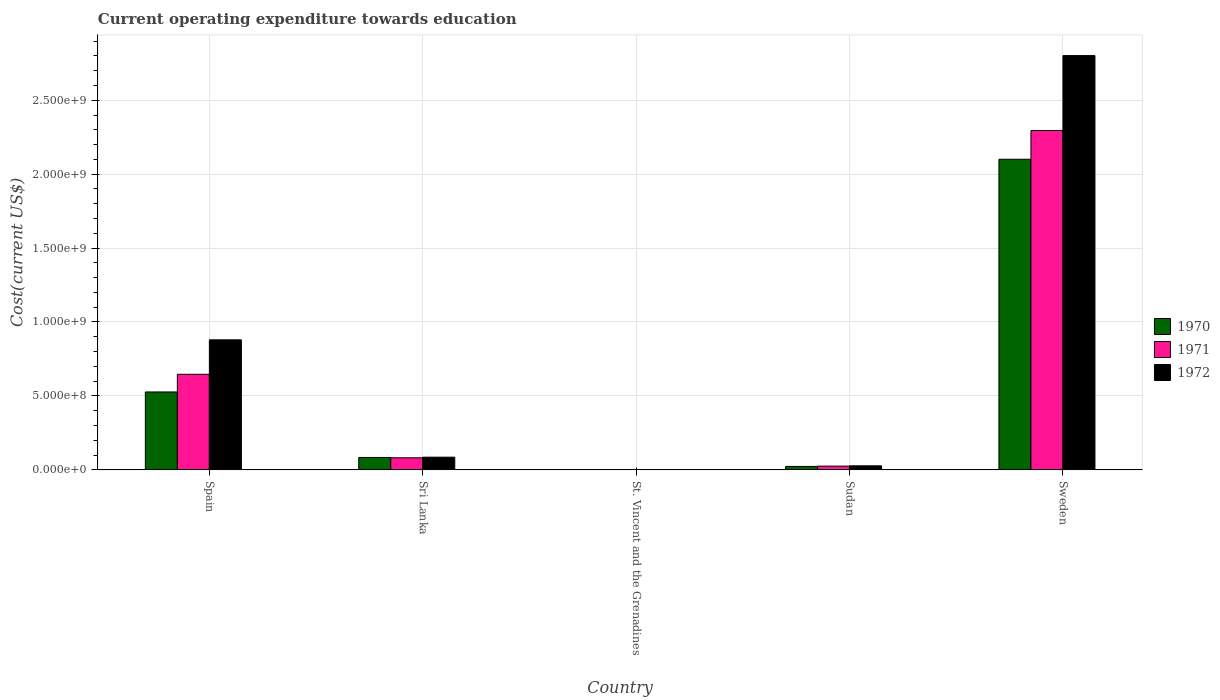How many different coloured bars are there?
Make the answer very short. 3. How many groups of bars are there?
Your response must be concise. 5. Are the number of bars per tick equal to the number of legend labels?
Provide a succinct answer. Yes. Are the number of bars on each tick of the X-axis equal?
Offer a very short reply. Yes. How many bars are there on the 5th tick from the left?
Provide a succinct answer. 3. What is the label of the 4th group of bars from the left?
Provide a succinct answer. Sudan. In how many cases, is the number of bars for a given country not equal to the number of legend labels?
Give a very brief answer. 0. What is the expenditure towards education in 1972 in Sweden?
Offer a terse response. 2.80e+09. Across all countries, what is the maximum expenditure towards education in 1971?
Offer a very short reply. 2.30e+09. Across all countries, what is the minimum expenditure towards education in 1971?
Offer a very short reply. 1.64e+06. In which country was the expenditure towards education in 1971 minimum?
Your response must be concise. St. Vincent and the Grenadines. What is the total expenditure towards education in 1971 in the graph?
Keep it short and to the point. 3.05e+09. What is the difference between the expenditure towards education in 1970 in Spain and that in Sudan?
Your response must be concise. 5.04e+08. What is the difference between the expenditure towards education in 1972 in Spain and the expenditure towards education in 1970 in Sweden?
Provide a short and direct response. -1.22e+09. What is the average expenditure towards education in 1970 per country?
Provide a succinct answer. 5.47e+08. What is the difference between the expenditure towards education of/in 1972 and expenditure towards education of/in 1970 in Sri Lanka?
Give a very brief answer. 1.91e+06. What is the ratio of the expenditure towards education in 1970 in Spain to that in Sri Lanka?
Ensure brevity in your answer.  6.3. Is the difference between the expenditure towards education in 1972 in Spain and St. Vincent and the Grenadines greater than the difference between the expenditure towards education in 1970 in Spain and St. Vincent and the Grenadines?
Ensure brevity in your answer.  Yes. What is the difference between the highest and the second highest expenditure towards education in 1972?
Keep it short and to the point. 1.92e+09. What is the difference between the highest and the lowest expenditure towards education in 1972?
Provide a short and direct response. 2.80e+09. In how many countries, is the expenditure towards education in 1971 greater than the average expenditure towards education in 1971 taken over all countries?
Your response must be concise. 2. Is the sum of the expenditure towards education in 1972 in Sudan and Sweden greater than the maximum expenditure towards education in 1971 across all countries?
Ensure brevity in your answer.  Yes. What does the 3rd bar from the left in Sudan represents?
Ensure brevity in your answer.  1972. What does the 3rd bar from the right in Sudan represents?
Your response must be concise. 1970. Is it the case that in every country, the sum of the expenditure towards education in 1971 and expenditure towards education in 1972 is greater than the expenditure towards education in 1970?
Your answer should be very brief. Yes. How many countries are there in the graph?
Your response must be concise. 5. Are the values on the major ticks of Y-axis written in scientific E-notation?
Give a very brief answer. Yes. Where does the legend appear in the graph?
Give a very brief answer. Center right. How many legend labels are there?
Make the answer very short. 3. What is the title of the graph?
Provide a succinct answer. Current operating expenditure towards education. What is the label or title of the X-axis?
Offer a very short reply. Country. What is the label or title of the Y-axis?
Give a very brief answer. Cost(current US$). What is the Cost(current US$) in 1970 in Spain?
Offer a terse response. 5.27e+08. What is the Cost(current US$) in 1971 in Spain?
Make the answer very short. 6.46e+08. What is the Cost(current US$) of 1972 in Spain?
Offer a terse response. 8.79e+08. What is the Cost(current US$) in 1970 in Sri Lanka?
Your answer should be very brief. 8.35e+07. What is the Cost(current US$) of 1971 in Sri Lanka?
Give a very brief answer. 8.13e+07. What is the Cost(current US$) of 1972 in Sri Lanka?
Make the answer very short. 8.55e+07. What is the Cost(current US$) in 1970 in St. Vincent and the Grenadines?
Your answer should be compact. 8.86e+05. What is the Cost(current US$) of 1971 in St. Vincent and the Grenadines?
Provide a succinct answer. 1.64e+06. What is the Cost(current US$) in 1972 in St. Vincent and the Grenadines?
Keep it short and to the point. 1.63e+06. What is the Cost(current US$) of 1970 in Sudan?
Your response must be concise. 2.29e+07. What is the Cost(current US$) in 1971 in Sudan?
Your answer should be very brief. 2.50e+07. What is the Cost(current US$) in 1972 in Sudan?
Offer a very short reply. 2.71e+07. What is the Cost(current US$) in 1970 in Sweden?
Offer a terse response. 2.10e+09. What is the Cost(current US$) in 1971 in Sweden?
Your response must be concise. 2.30e+09. What is the Cost(current US$) of 1972 in Sweden?
Provide a succinct answer. 2.80e+09. Across all countries, what is the maximum Cost(current US$) in 1970?
Your answer should be compact. 2.10e+09. Across all countries, what is the maximum Cost(current US$) in 1971?
Offer a terse response. 2.30e+09. Across all countries, what is the maximum Cost(current US$) in 1972?
Offer a very short reply. 2.80e+09. Across all countries, what is the minimum Cost(current US$) in 1970?
Your answer should be compact. 8.86e+05. Across all countries, what is the minimum Cost(current US$) of 1971?
Provide a succinct answer. 1.64e+06. Across all countries, what is the minimum Cost(current US$) of 1972?
Offer a very short reply. 1.63e+06. What is the total Cost(current US$) of 1970 in the graph?
Offer a terse response. 2.73e+09. What is the total Cost(current US$) in 1971 in the graph?
Offer a terse response. 3.05e+09. What is the total Cost(current US$) of 1972 in the graph?
Make the answer very short. 3.80e+09. What is the difference between the Cost(current US$) of 1970 in Spain and that in Sri Lanka?
Provide a succinct answer. 4.43e+08. What is the difference between the Cost(current US$) of 1971 in Spain and that in Sri Lanka?
Offer a terse response. 5.65e+08. What is the difference between the Cost(current US$) of 1972 in Spain and that in Sri Lanka?
Your response must be concise. 7.94e+08. What is the difference between the Cost(current US$) of 1970 in Spain and that in St. Vincent and the Grenadines?
Your answer should be very brief. 5.26e+08. What is the difference between the Cost(current US$) in 1971 in Spain and that in St. Vincent and the Grenadines?
Your response must be concise. 6.44e+08. What is the difference between the Cost(current US$) in 1972 in Spain and that in St. Vincent and the Grenadines?
Keep it short and to the point. 8.78e+08. What is the difference between the Cost(current US$) of 1970 in Spain and that in Sudan?
Offer a very short reply. 5.04e+08. What is the difference between the Cost(current US$) of 1971 in Spain and that in Sudan?
Make the answer very short. 6.21e+08. What is the difference between the Cost(current US$) of 1972 in Spain and that in Sudan?
Ensure brevity in your answer.  8.52e+08. What is the difference between the Cost(current US$) in 1970 in Spain and that in Sweden?
Make the answer very short. -1.57e+09. What is the difference between the Cost(current US$) in 1971 in Spain and that in Sweden?
Keep it short and to the point. -1.65e+09. What is the difference between the Cost(current US$) of 1972 in Spain and that in Sweden?
Make the answer very short. -1.92e+09. What is the difference between the Cost(current US$) in 1970 in Sri Lanka and that in St. Vincent and the Grenadines?
Provide a succinct answer. 8.27e+07. What is the difference between the Cost(current US$) in 1971 in Sri Lanka and that in St. Vincent and the Grenadines?
Ensure brevity in your answer.  7.96e+07. What is the difference between the Cost(current US$) in 1972 in Sri Lanka and that in St. Vincent and the Grenadines?
Give a very brief answer. 8.38e+07. What is the difference between the Cost(current US$) of 1970 in Sri Lanka and that in Sudan?
Make the answer very short. 6.06e+07. What is the difference between the Cost(current US$) of 1971 in Sri Lanka and that in Sudan?
Your response must be concise. 5.63e+07. What is the difference between the Cost(current US$) of 1972 in Sri Lanka and that in Sudan?
Offer a very short reply. 5.84e+07. What is the difference between the Cost(current US$) of 1970 in Sri Lanka and that in Sweden?
Keep it short and to the point. -2.02e+09. What is the difference between the Cost(current US$) in 1971 in Sri Lanka and that in Sweden?
Provide a succinct answer. -2.21e+09. What is the difference between the Cost(current US$) in 1972 in Sri Lanka and that in Sweden?
Offer a terse response. -2.72e+09. What is the difference between the Cost(current US$) of 1970 in St. Vincent and the Grenadines and that in Sudan?
Your response must be concise. -2.21e+07. What is the difference between the Cost(current US$) in 1971 in St. Vincent and the Grenadines and that in Sudan?
Your response must be concise. -2.33e+07. What is the difference between the Cost(current US$) of 1972 in St. Vincent and the Grenadines and that in Sudan?
Your answer should be very brief. -2.54e+07. What is the difference between the Cost(current US$) of 1970 in St. Vincent and the Grenadines and that in Sweden?
Your answer should be very brief. -2.10e+09. What is the difference between the Cost(current US$) of 1971 in St. Vincent and the Grenadines and that in Sweden?
Offer a very short reply. -2.29e+09. What is the difference between the Cost(current US$) in 1972 in St. Vincent and the Grenadines and that in Sweden?
Provide a succinct answer. -2.80e+09. What is the difference between the Cost(current US$) in 1970 in Sudan and that in Sweden?
Your response must be concise. -2.08e+09. What is the difference between the Cost(current US$) of 1971 in Sudan and that in Sweden?
Make the answer very short. -2.27e+09. What is the difference between the Cost(current US$) in 1972 in Sudan and that in Sweden?
Keep it short and to the point. -2.78e+09. What is the difference between the Cost(current US$) in 1970 in Spain and the Cost(current US$) in 1971 in Sri Lanka?
Keep it short and to the point. 4.45e+08. What is the difference between the Cost(current US$) in 1970 in Spain and the Cost(current US$) in 1972 in Sri Lanka?
Give a very brief answer. 4.41e+08. What is the difference between the Cost(current US$) of 1971 in Spain and the Cost(current US$) of 1972 in Sri Lanka?
Your response must be concise. 5.61e+08. What is the difference between the Cost(current US$) of 1970 in Spain and the Cost(current US$) of 1971 in St. Vincent and the Grenadines?
Your response must be concise. 5.25e+08. What is the difference between the Cost(current US$) in 1970 in Spain and the Cost(current US$) in 1972 in St. Vincent and the Grenadines?
Give a very brief answer. 5.25e+08. What is the difference between the Cost(current US$) of 1971 in Spain and the Cost(current US$) of 1972 in St. Vincent and the Grenadines?
Your answer should be very brief. 6.45e+08. What is the difference between the Cost(current US$) of 1970 in Spain and the Cost(current US$) of 1971 in Sudan?
Ensure brevity in your answer.  5.02e+08. What is the difference between the Cost(current US$) of 1970 in Spain and the Cost(current US$) of 1972 in Sudan?
Keep it short and to the point. 5.00e+08. What is the difference between the Cost(current US$) of 1971 in Spain and the Cost(current US$) of 1972 in Sudan?
Give a very brief answer. 6.19e+08. What is the difference between the Cost(current US$) in 1970 in Spain and the Cost(current US$) in 1971 in Sweden?
Your response must be concise. -1.77e+09. What is the difference between the Cost(current US$) in 1970 in Spain and the Cost(current US$) in 1972 in Sweden?
Your answer should be very brief. -2.28e+09. What is the difference between the Cost(current US$) of 1971 in Spain and the Cost(current US$) of 1972 in Sweden?
Make the answer very short. -2.16e+09. What is the difference between the Cost(current US$) in 1970 in Sri Lanka and the Cost(current US$) in 1971 in St. Vincent and the Grenadines?
Your response must be concise. 8.19e+07. What is the difference between the Cost(current US$) of 1970 in Sri Lanka and the Cost(current US$) of 1972 in St. Vincent and the Grenadines?
Your response must be concise. 8.19e+07. What is the difference between the Cost(current US$) in 1971 in Sri Lanka and the Cost(current US$) in 1972 in St. Vincent and the Grenadines?
Ensure brevity in your answer.  7.97e+07. What is the difference between the Cost(current US$) in 1970 in Sri Lanka and the Cost(current US$) in 1971 in Sudan?
Offer a terse response. 5.86e+07. What is the difference between the Cost(current US$) of 1970 in Sri Lanka and the Cost(current US$) of 1972 in Sudan?
Offer a very short reply. 5.65e+07. What is the difference between the Cost(current US$) in 1971 in Sri Lanka and the Cost(current US$) in 1972 in Sudan?
Your answer should be compact. 5.42e+07. What is the difference between the Cost(current US$) in 1970 in Sri Lanka and the Cost(current US$) in 1971 in Sweden?
Your response must be concise. -2.21e+09. What is the difference between the Cost(current US$) of 1970 in Sri Lanka and the Cost(current US$) of 1972 in Sweden?
Your answer should be very brief. -2.72e+09. What is the difference between the Cost(current US$) in 1971 in Sri Lanka and the Cost(current US$) in 1972 in Sweden?
Provide a succinct answer. -2.72e+09. What is the difference between the Cost(current US$) in 1970 in St. Vincent and the Grenadines and the Cost(current US$) in 1971 in Sudan?
Offer a terse response. -2.41e+07. What is the difference between the Cost(current US$) of 1970 in St. Vincent and the Grenadines and the Cost(current US$) of 1972 in Sudan?
Keep it short and to the point. -2.62e+07. What is the difference between the Cost(current US$) in 1971 in St. Vincent and the Grenadines and the Cost(current US$) in 1972 in Sudan?
Your response must be concise. -2.54e+07. What is the difference between the Cost(current US$) in 1970 in St. Vincent and the Grenadines and the Cost(current US$) in 1971 in Sweden?
Provide a succinct answer. -2.29e+09. What is the difference between the Cost(current US$) of 1970 in St. Vincent and the Grenadines and the Cost(current US$) of 1972 in Sweden?
Your response must be concise. -2.80e+09. What is the difference between the Cost(current US$) of 1971 in St. Vincent and the Grenadines and the Cost(current US$) of 1972 in Sweden?
Your response must be concise. -2.80e+09. What is the difference between the Cost(current US$) in 1970 in Sudan and the Cost(current US$) in 1971 in Sweden?
Your response must be concise. -2.27e+09. What is the difference between the Cost(current US$) in 1970 in Sudan and the Cost(current US$) in 1972 in Sweden?
Ensure brevity in your answer.  -2.78e+09. What is the difference between the Cost(current US$) of 1971 in Sudan and the Cost(current US$) of 1972 in Sweden?
Your response must be concise. -2.78e+09. What is the average Cost(current US$) in 1970 per country?
Provide a succinct answer. 5.47e+08. What is the average Cost(current US$) of 1971 per country?
Your answer should be very brief. 6.10e+08. What is the average Cost(current US$) in 1972 per country?
Give a very brief answer. 7.59e+08. What is the difference between the Cost(current US$) in 1970 and Cost(current US$) in 1971 in Spain?
Keep it short and to the point. -1.19e+08. What is the difference between the Cost(current US$) in 1970 and Cost(current US$) in 1972 in Spain?
Offer a very short reply. -3.53e+08. What is the difference between the Cost(current US$) in 1971 and Cost(current US$) in 1972 in Spain?
Keep it short and to the point. -2.33e+08. What is the difference between the Cost(current US$) of 1970 and Cost(current US$) of 1971 in Sri Lanka?
Your response must be concise. 2.25e+06. What is the difference between the Cost(current US$) in 1970 and Cost(current US$) in 1972 in Sri Lanka?
Make the answer very short. -1.91e+06. What is the difference between the Cost(current US$) of 1971 and Cost(current US$) of 1972 in Sri Lanka?
Your response must be concise. -4.17e+06. What is the difference between the Cost(current US$) of 1970 and Cost(current US$) of 1971 in St. Vincent and the Grenadines?
Your response must be concise. -7.59e+05. What is the difference between the Cost(current US$) in 1970 and Cost(current US$) in 1972 in St. Vincent and the Grenadines?
Your response must be concise. -7.42e+05. What is the difference between the Cost(current US$) in 1971 and Cost(current US$) in 1972 in St. Vincent and the Grenadines?
Make the answer very short. 1.67e+04. What is the difference between the Cost(current US$) in 1970 and Cost(current US$) in 1971 in Sudan?
Offer a very short reply. -2.02e+06. What is the difference between the Cost(current US$) of 1970 and Cost(current US$) of 1972 in Sudan?
Give a very brief answer. -4.12e+06. What is the difference between the Cost(current US$) of 1971 and Cost(current US$) of 1972 in Sudan?
Give a very brief answer. -2.10e+06. What is the difference between the Cost(current US$) of 1970 and Cost(current US$) of 1971 in Sweden?
Ensure brevity in your answer.  -1.95e+08. What is the difference between the Cost(current US$) of 1970 and Cost(current US$) of 1972 in Sweden?
Offer a terse response. -7.01e+08. What is the difference between the Cost(current US$) of 1971 and Cost(current US$) of 1972 in Sweden?
Your answer should be compact. -5.07e+08. What is the ratio of the Cost(current US$) in 1970 in Spain to that in Sri Lanka?
Your answer should be very brief. 6.3. What is the ratio of the Cost(current US$) in 1971 in Spain to that in Sri Lanka?
Make the answer very short. 7.95. What is the ratio of the Cost(current US$) of 1972 in Spain to that in Sri Lanka?
Your response must be concise. 10.29. What is the ratio of the Cost(current US$) of 1970 in Spain to that in St. Vincent and the Grenadines?
Make the answer very short. 594.67. What is the ratio of the Cost(current US$) in 1971 in Spain to that in St. Vincent and the Grenadines?
Offer a terse response. 392.97. What is the ratio of the Cost(current US$) in 1972 in Spain to that in St. Vincent and the Grenadines?
Offer a very short reply. 540.2. What is the ratio of the Cost(current US$) in 1970 in Spain to that in Sudan?
Ensure brevity in your answer.  22.95. What is the ratio of the Cost(current US$) of 1971 in Spain to that in Sudan?
Make the answer very short. 25.87. What is the ratio of the Cost(current US$) in 1972 in Spain to that in Sudan?
Offer a terse response. 32.48. What is the ratio of the Cost(current US$) of 1970 in Spain to that in Sweden?
Provide a short and direct response. 0.25. What is the ratio of the Cost(current US$) of 1971 in Spain to that in Sweden?
Your answer should be compact. 0.28. What is the ratio of the Cost(current US$) of 1972 in Spain to that in Sweden?
Keep it short and to the point. 0.31. What is the ratio of the Cost(current US$) of 1970 in Sri Lanka to that in St. Vincent and the Grenadines?
Keep it short and to the point. 94.34. What is the ratio of the Cost(current US$) in 1971 in Sri Lanka to that in St. Vincent and the Grenadines?
Your answer should be compact. 49.44. What is the ratio of the Cost(current US$) of 1972 in Sri Lanka to that in St. Vincent and the Grenadines?
Ensure brevity in your answer.  52.51. What is the ratio of the Cost(current US$) of 1970 in Sri Lanka to that in Sudan?
Your response must be concise. 3.64. What is the ratio of the Cost(current US$) in 1971 in Sri Lanka to that in Sudan?
Your response must be concise. 3.26. What is the ratio of the Cost(current US$) of 1972 in Sri Lanka to that in Sudan?
Make the answer very short. 3.16. What is the ratio of the Cost(current US$) of 1970 in Sri Lanka to that in Sweden?
Give a very brief answer. 0.04. What is the ratio of the Cost(current US$) of 1971 in Sri Lanka to that in Sweden?
Offer a terse response. 0.04. What is the ratio of the Cost(current US$) in 1972 in Sri Lanka to that in Sweden?
Provide a succinct answer. 0.03. What is the ratio of the Cost(current US$) in 1970 in St. Vincent and the Grenadines to that in Sudan?
Offer a very short reply. 0.04. What is the ratio of the Cost(current US$) of 1971 in St. Vincent and the Grenadines to that in Sudan?
Keep it short and to the point. 0.07. What is the ratio of the Cost(current US$) of 1972 in St. Vincent and the Grenadines to that in Sudan?
Your response must be concise. 0.06. What is the ratio of the Cost(current US$) of 1971 in St. Vincent and the Grenadines to that in Sweden?
Offer a very short reply. 0. What is the ratio of the Cost(current US$) of 1972 in St. Vincent and the Grenadines to that in Sweden?
Ensure brevity in your answer.  0. What is the ratio of the Cost(current US$) in 1970 in Sudan to that in Sweden?
Ensure brevity in your answer.  0.01. What is the ratio of the Cost(current US$) of 1971 in Sudan to that in Sweden?
Your answer should be compact. 0.01. What is the ratio of the Cost(current US$) in 1972 in Sudan to that in Sweden?
Make the answer very short. 0.01. What is the difference between the highest and the second highest Cost(current US$) of 1970?
Make the answer very short. 1.57e+09. What is the difference between the highest and the second highest Cost(current US$) of 1971?
Offer a terse response. 1.65e+09. What is the difference between the highest and the second highest Cost(current US$) in 1972?
Ensure brevity in your answer.  1.92e+09. What is the difference between the highest and the lowest Cost(current US$) of 1970?
Your answer should be very brief. 2.10e+09. What is the difference between the highest and the lowest Cost(current US$) of 1971?
Keep it short and to the point. 2.29e+09. What is the difference between the highest and the lowest Cost(current US$) of 1972?
Make the answer very short. 2.80e+09. 